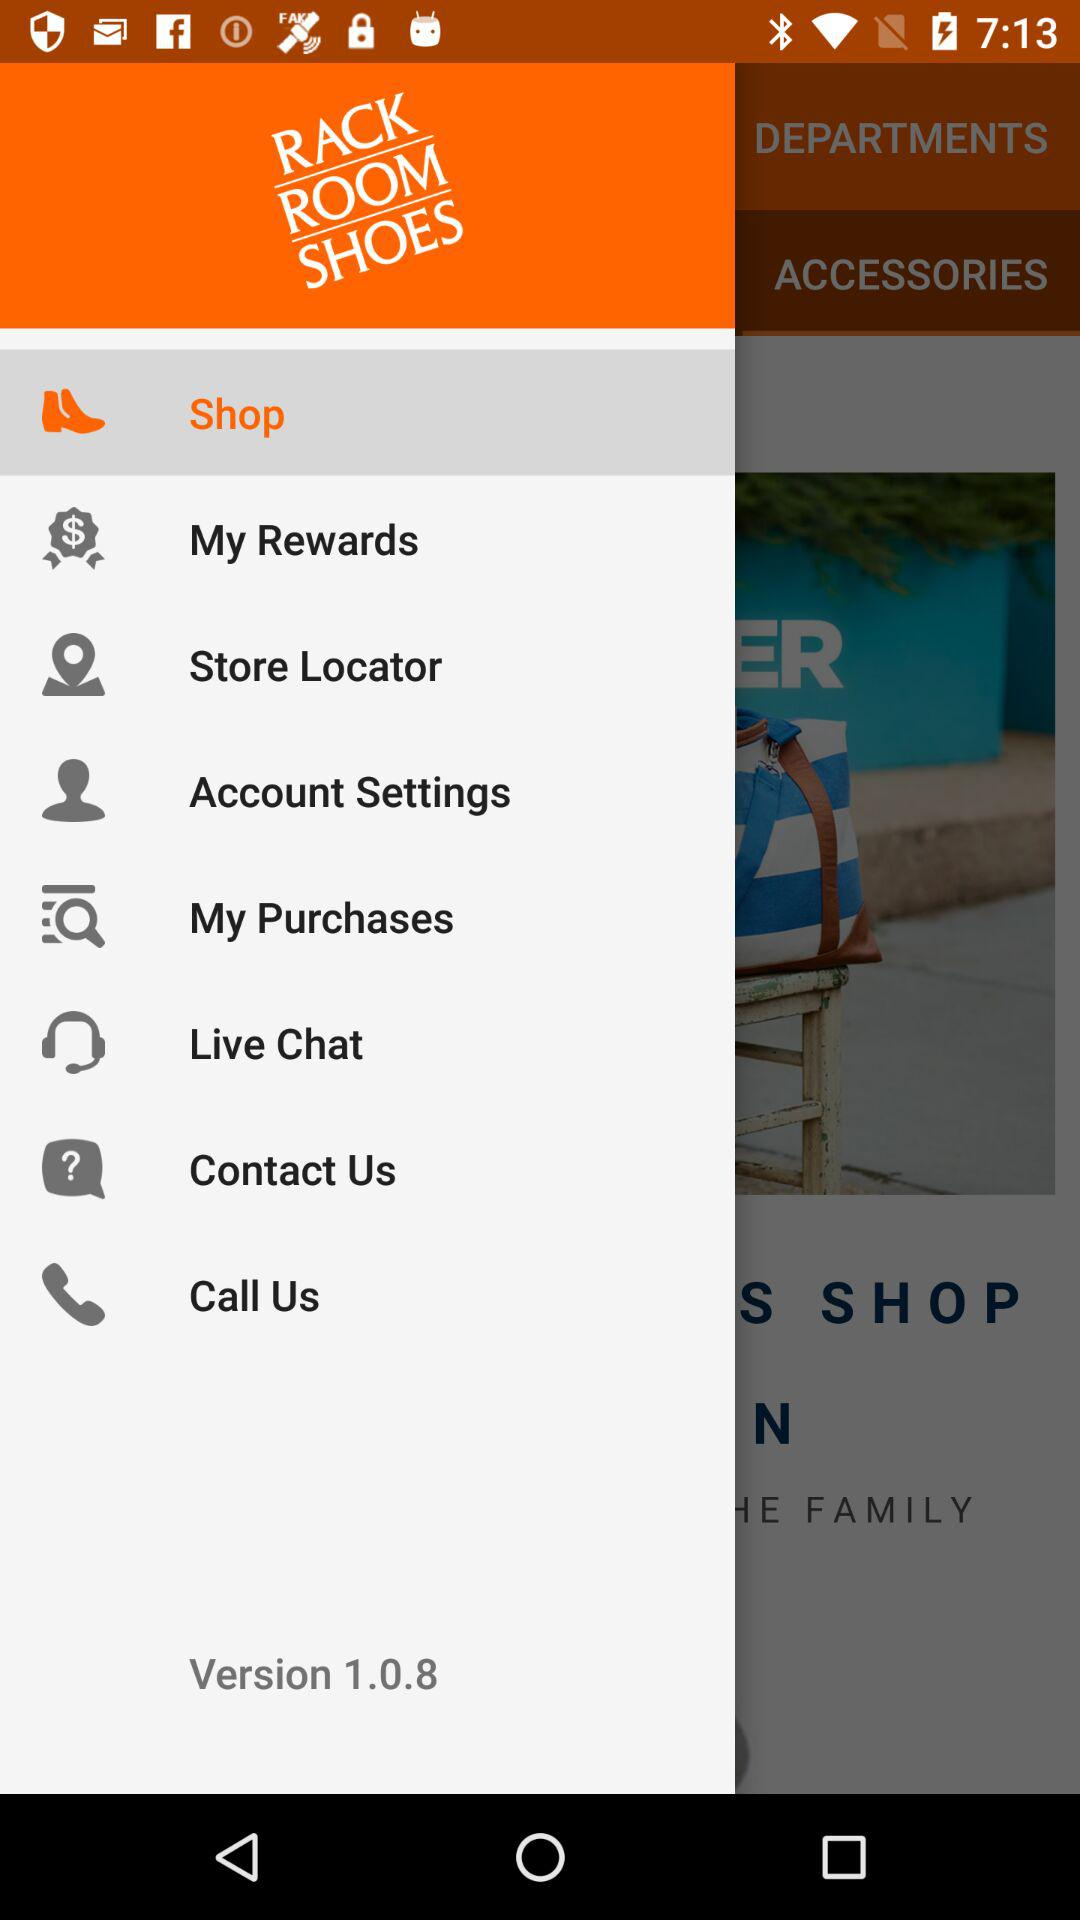What is the selected option? The selected option is "Shop". 